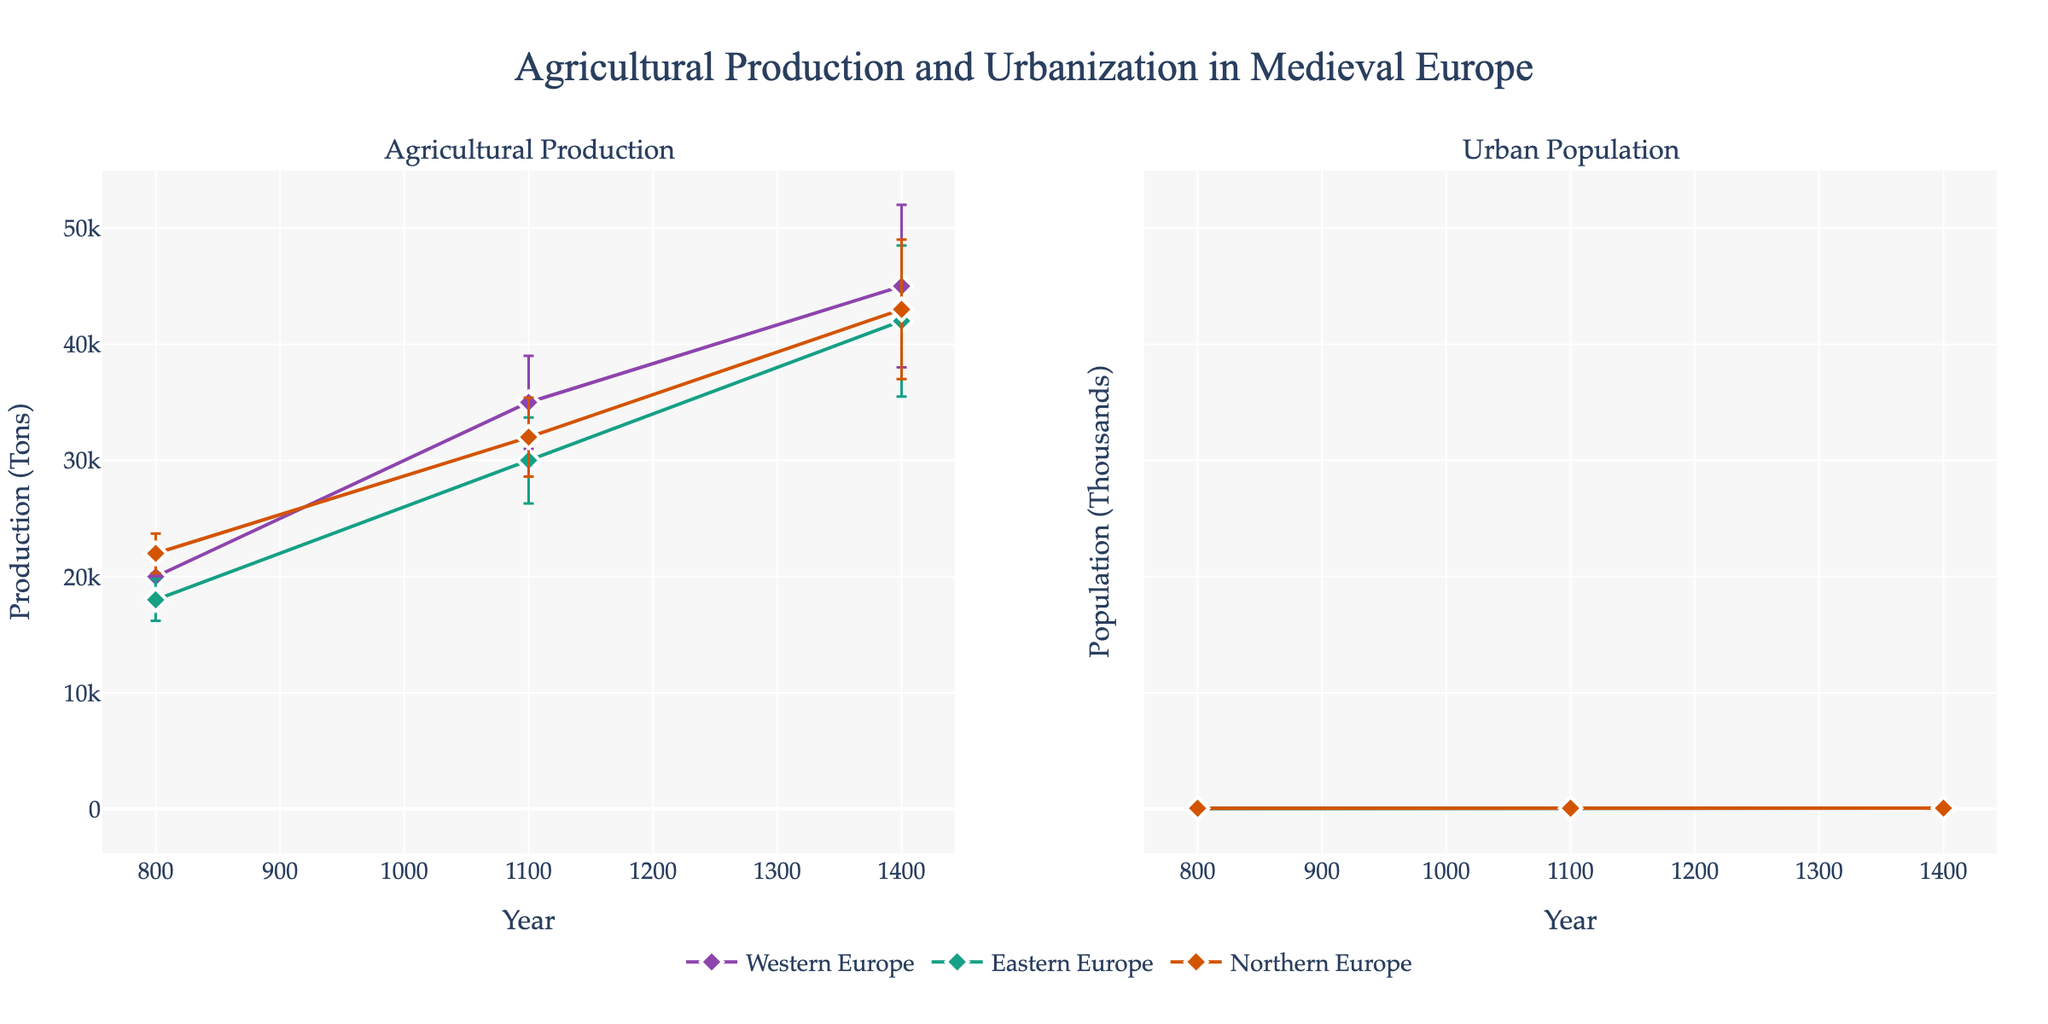What is the title of the figure? The title is prominently displayed at the top of the figure, reading "Agricultural Production and Urbanization in Medieval Europe".
Answer: Agricultural Production and Urbanization in Medieval Europe Which region had the highest urban population in the High Middle Ages? To find this, look at the Urban Population subplot for the High Middle Ages (1100) and compare the data points for Western Europe, Eastern Europe, and Northern Europe. Western Europe had 4000 thousands, which is the highest.
Answer: Western Europe How does agricultural production in Eastern Europe change from the Early Middle Ages to the Late Middle Ages? Compare the Agricultural Production values of Eastern Europe at 800 (Early Middle Ages) and 1400 (Late Middle Ages). They increase from 18000 tons to 42000 tons.
Answer: It increases from 18000 tons to 42000 tons What is the urban population difference between Northern Europe and Eastern Europe in 1100? Look at the Urban Population subplot for the year 1100. Northern Europe has 3400 thousands, and Eastern Europe has 3700 thousands. The difference is 3700 - 3400 = 300 thousands.
Answer: 300 thousands Which region shows the greatest change in agricultural production from the Early Middle Ages to the Late Middle Ages? Compare the changes for each region: Western Europe (20000 to 45000 = 25000 tons), Eastern Europe (18000 to 42000 = 24000 tons), and Northern Europe (22000 to 43000 = 21000 tons). Western Europe shows the greatest change.
Answer: Western Europe How are the error bars for agricultural production in Northern Europe depicted in the figure? In the Agricultural Production subplot, error bars are depicted as vertical lines extending from the data points, with diamond markers. They indicate the possible range of values based on the error margin.
Answer: As vertical lines with diamond markers Is there a visible correlation between agricultural production and urban population in any of the regions from the Early to High Middle Ages? Look at the trends from the Early to High Middle Ages (800 to 1100) in both subplots for each region. For Western Europe - both production and population increase, suggesting a positive correlation. For Eastern and Northern Europe - similar increasing trends suggest positive correlations as well.
Answer: Yes, positive correlation in all regions Which region had the lowest agricultural production in the Early Middle Ages and what was the value? Look at the values in the Agricultural Production subplot for 800. Eastern Europe has the lowest value at 18000 tons.
Answer: Eastern Europe, 18000 tons What is the average urban population of Western Europe over the three periods (800, 1100, 1400)? Calculate the average for Western Europe: (2000 + 4000 + 7000) / 3 = 13000 / 3 = 4333.33 thousands.
Answer: 4333.33 thousands Explain the trend in agricultural production for all regions from the Early Middle Ages to the Late Middle Ages. Identify the trend lines for each region over the periods. For Western Europe, it goes from 20000 to 45000 tons. Eastern Europe increases from 18000 to 42000 tons. Northern Europe increases from 22000 to 43000 tons. All regions show an increasing trend in agricultural production.
Answer: All regions show increasing trends 